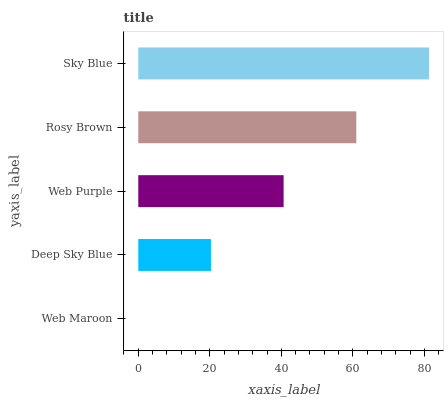Is Web Maroon the minimum?
Answer yes or no. Yes. Is Sky Blue the maximum?
Answer yes or no. Yes. Is Deep Sky Blue the minimum?
Answer yes or no. No. Is Deep Sky Blue the maximum?
Answer yes or no. No. Is Deep Sky Blue greater than Web Maroon?
Answer yes or no. Yes. Is Web Maroon less than Deep Sky Blue?
Answer yes or no. Yes. Is Web Maroon greater than Deep Sky Blue?
Answer yes or no. No. Is Deep Sky Blue less than Web Maroon?
Answer yes or no. No. Is Web Purple the high median?
Answer yes or no. Yes. Is Web Purple the low median?
Answer yes or no. Yes. Is Rosy Brown the high median?
Answer yes or no. No. Is Rosy Brown the low median?
Answer yes or no. No. 